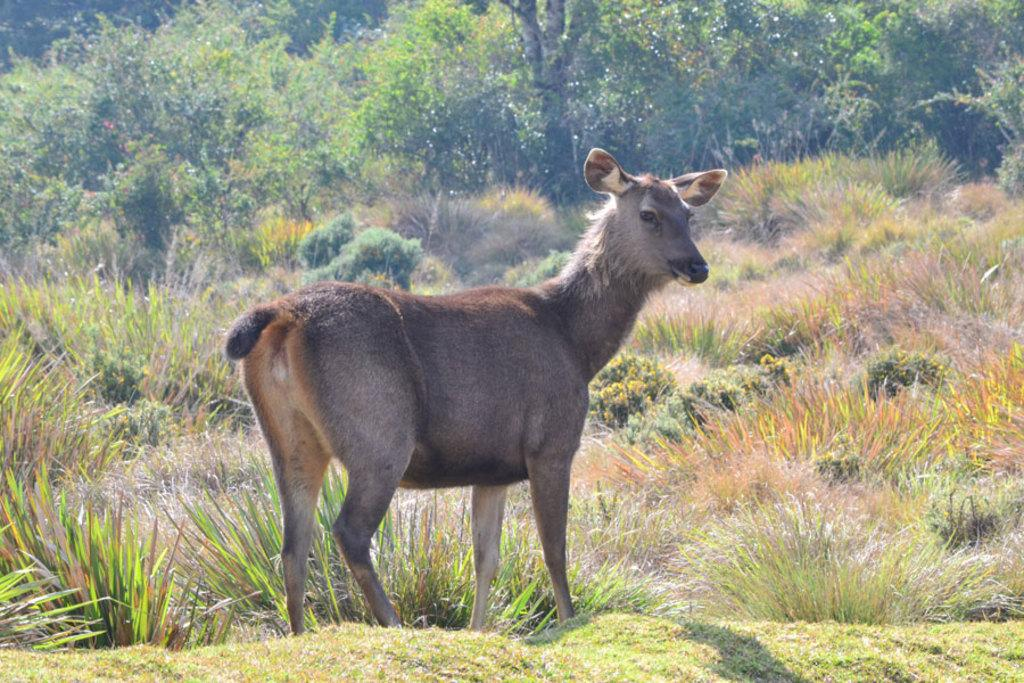What type of animal can be seen in the image? There is a deer in the image. What natural elements are present in the image? There are trees, plants, and grass in the image. What type of lamp is hanging from the deer's antlers in the image? There is no lamp present in the image; it features a deer in a natural setting with trees, plants, and grass. 